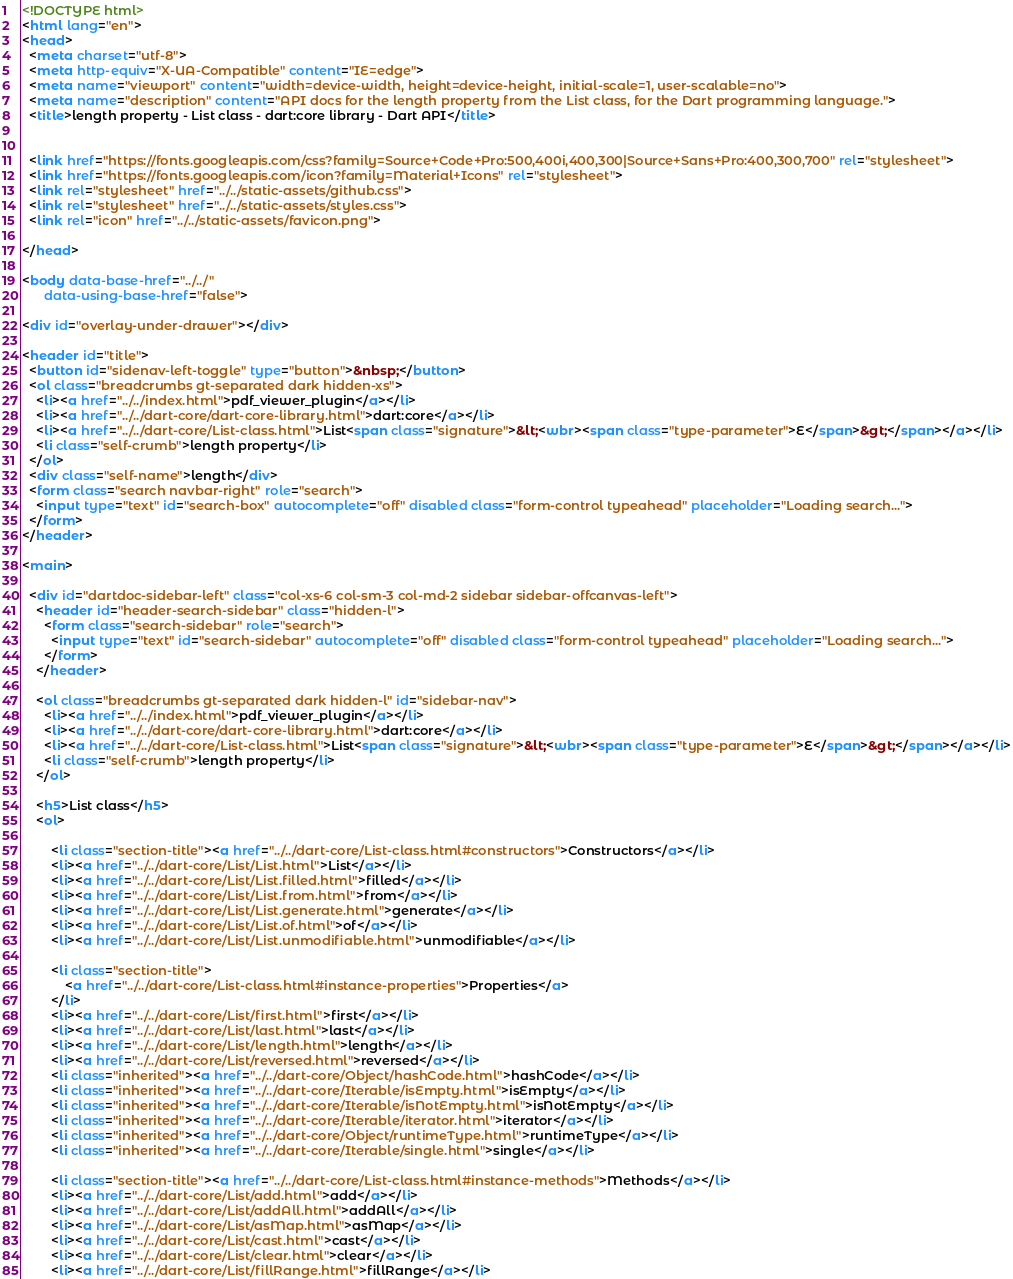Convert code to text. <code><loc_0><loc_0><loc_500><loc_500><_HTML_><!DOCTYPE html>
<html lang="en">
<head>
  <meta charset="utf-8">
  <meta http-equiv="X-UA-Compatible" content="IE=edge">
  <meta name="viewport" content="width=device-width, height=device-height, initial-scale=1, user-scalable=no">
  <meta name="description" content="API docs for the length property from the List class, for the Dart programming language.">
  <title>length property - List class - dart:core library - Dart API</title>

  
  <link href="https://fonts.googleapis.com/css?family=Source+Code+Pro:500,400i,400,300|Source+Sans+Pro:400,300,700" rel="stylesheet">
  <link href="https://fonts.googleapis.com/icon?family=Material+Icons" rel="stylesheet">
  <link rel="stylesheet" href="../../static-assets/github.css">
  <link rel="stylesheet" href="../../static-assets/styles.css">
  <link rel="icon" href="../../static-assets/favicon.png">

</head>

<body data-base-href="../../"
      data-using-base-href="false">

<div id="overlay-under-drawer"></div>

<header id="title">
  <button id="sidenav-left-toggle" type="button">&nbsp;</button>
  <ol class="breadcrumbs gt-separated dark hidden-xs">
    <li><a href="../../index.html">pdf_viewer_plugin</a></li>
    <li><a href="../../dart-core/dart-core-library.html">dart:core</a></li>
    <li><a href="../../dart-core/List-class.html">List<span class="signature">&lt;<wbr><span class="type-parameter">E</span>&gt;</span></a></li>
    <li class="self-crumb">length property</li>
  </ol>
  <div class="self-name">length</div>
  <form class="search navbar-right" role="search">
    <input type="text" id="search-box" autocomplete="off" disabled class="form-control typeahead" placeholder="Loading search...">
  </form>
</header>

<main>

  <div id="dartdoc-sidebar-left" class="col-xs-6 col-sm-3 col-md-2 sidebar sidebar-offcanvas-left">
    <header id="header-search-sidebar" class="hidden-l">
      <form class="search-sidebar" role="search">
        <input type="text" id="search-sidebar" autocomplete="off" disabled class="form-control typeahead" placeholder="Loading search...">
      </form>
    </header>
    
    <ol class="breadcrumbs gt-separated dark hidden-l" id="sidebar-nav">
      <li><a href="../../index.html">pdf_viewer_plugin</a></li>
      <li><a href="../../dart-core/dart-core-library.html">dart:core</a></li>
      <li><a href="../../dart-core/List-class.html">List<span class="signature">&lt;<wbr><span class="type-parameter">E</span>&gt;</span></a></li>
      <li class="self-crumb">length property</li>
    </ol>
    
    <h5>List class</h5>
    <ol>
    
        <li class="section-title"><a href="../../dart-core/List-class.html#constructors">Constructors</a></li>
        <li><a href="../../dart-core/List/List.html">List</a></li>
        <li><a href="../../dart-core/List/List.filled.html">filled</a></li>
        <li><a href="../../dart-core/List/List.from.html">from</a></li>
        <li><a href="../../dart-core/List/List.generate.html">generate</a></li>
        <li><a href="../../dart-core/List/List.of.html">of</a></li>
        <li><a href="../../dart-core/List/List.unmodifiable.html">unmodifiable</a></li>
    
        <li class="section-title">
            <a href="../../dart-core/List-class.html#instance-properties">Properties</a>
        </li>
        <li><a href="../../dart-core/List/first.html">first</a></li>
        <li><a href="../../dart-core/List/last.html">last</a></li>
        <li><a href="../../dart-core/List/length.html">length</a></li>
        <li><a href="../../dart-core/List/reversed.html">reversed</a></li>
        <li class="inherited"><a href="../../dart-core/Object/hashCode.html">hashCode</a></li>
        <li class="inherited"><a href="../../dart-core/Iterable/isEmpty.html">isEmpty</a></li>
        <li class="inherited"><a href="../../dart-core/Iterable/isNotEmpty.html">isNotEmpty</a></li>
        <li class="inherited"><a href="../../dart-core/Iterable/iterator.html">iterator</a></li>
        <li class="inherited"><a href="../../dart-core/Object/runtimeType.html">runtimeType</a></li>
        <li class="inherited"><a href="../../dart-core/Iterable/single.html">single</a></li>
    
        <li class="section-title"><a href="../../dart-core/List-class.html#instance-methods">Methods</a></li>
        <li><a href="../../dart-core/List/add.html">add</a></li>
        <li><a href="../../dart-core/List/addAll.html">addAll</a></li>
        <li><a href="../../dart-core/List/asMap.html">asMap</a></li>
        <li><a href="../../dart-core/List/cast.html">cast</a></li>
        <li><a href="../../dart-core/List/clear.html">clear</a></li>
        <li><a href="../../dart-core/List/fillRange.html">fillRange</a></li></code> 